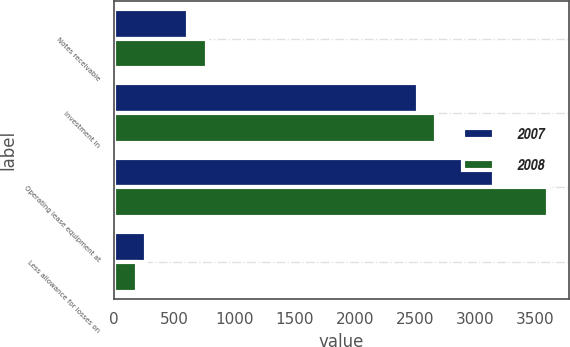<chart> <loc_0><loc_0><loc_500><loc_500><stacked_bar_chart><ecel><fcel>Notes receivable<fcel>Investment in<fcel>Operating lease equipment at<fcel>Less allowance for losses on<nl><fcel>2007<fcel>615<fcel>2528<fcel>3152<fcel>269<nl><fcel>2008<fcel>770<fcel>2676<fcel>3601<fcel>195<nl></chart> 